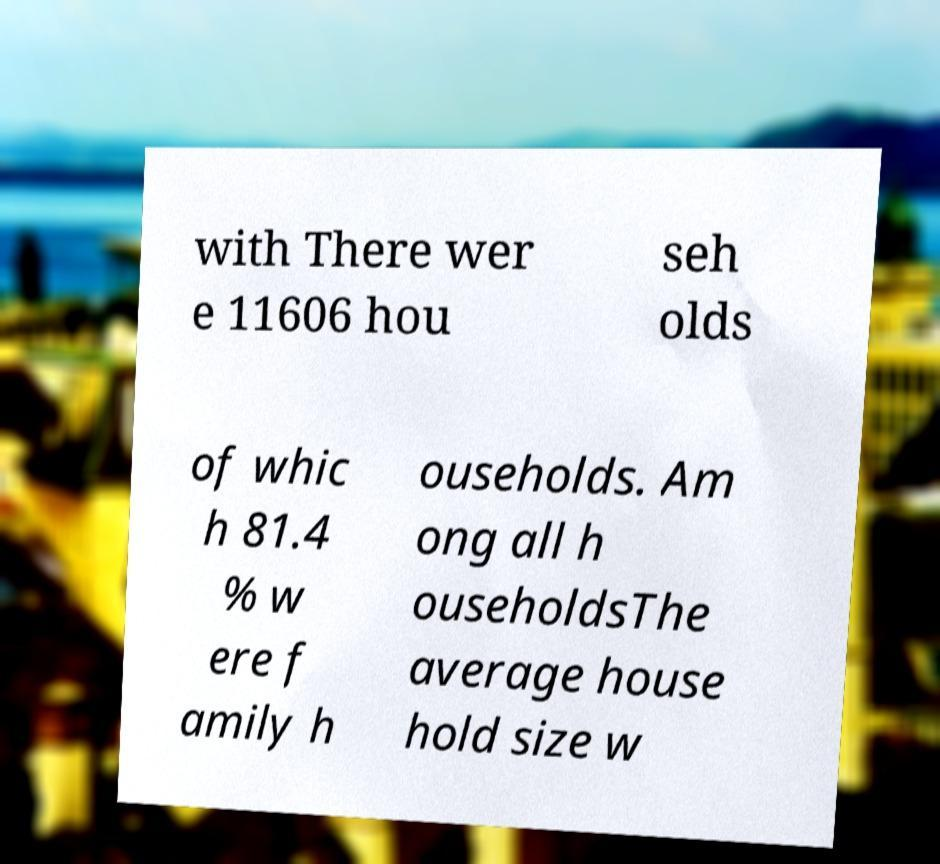Can you read and provide the text displayed in the image?This photo seems to have some interesting text. Can you extract and type it out for me? with There wer e 11606 hou seh olds of whic h 81.4 % w ere f amily h ouseholds. Am ong all h ouseholdsThe average house hold size w 